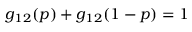<formula> <loc_0><loc_0><loc_500><loc_500>\begin{array} { r } { g _ { 1 2 } ( p ) + g _ { 1 2 } ( 1 - p ) = 1 } \end{array}</formula> 